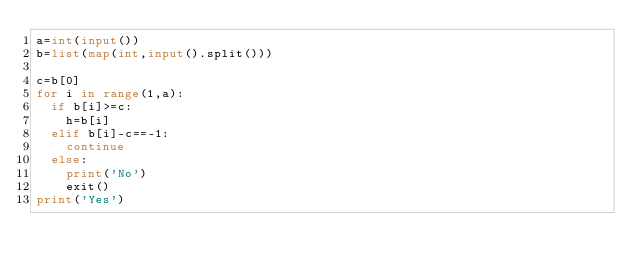Convert code to text. <code><loc_0><loc_0><loc_500><loc_500><_Python_>a=int(input())
b=list(map(int,input().split()))
 
c=b[0]
for i in range(1,a):
  if b[i]>=c:
    h=b[i]
  elif b[i]-c==-1:
    continue
  else:
    print('No')
    exit()
print('Yes')</code> 